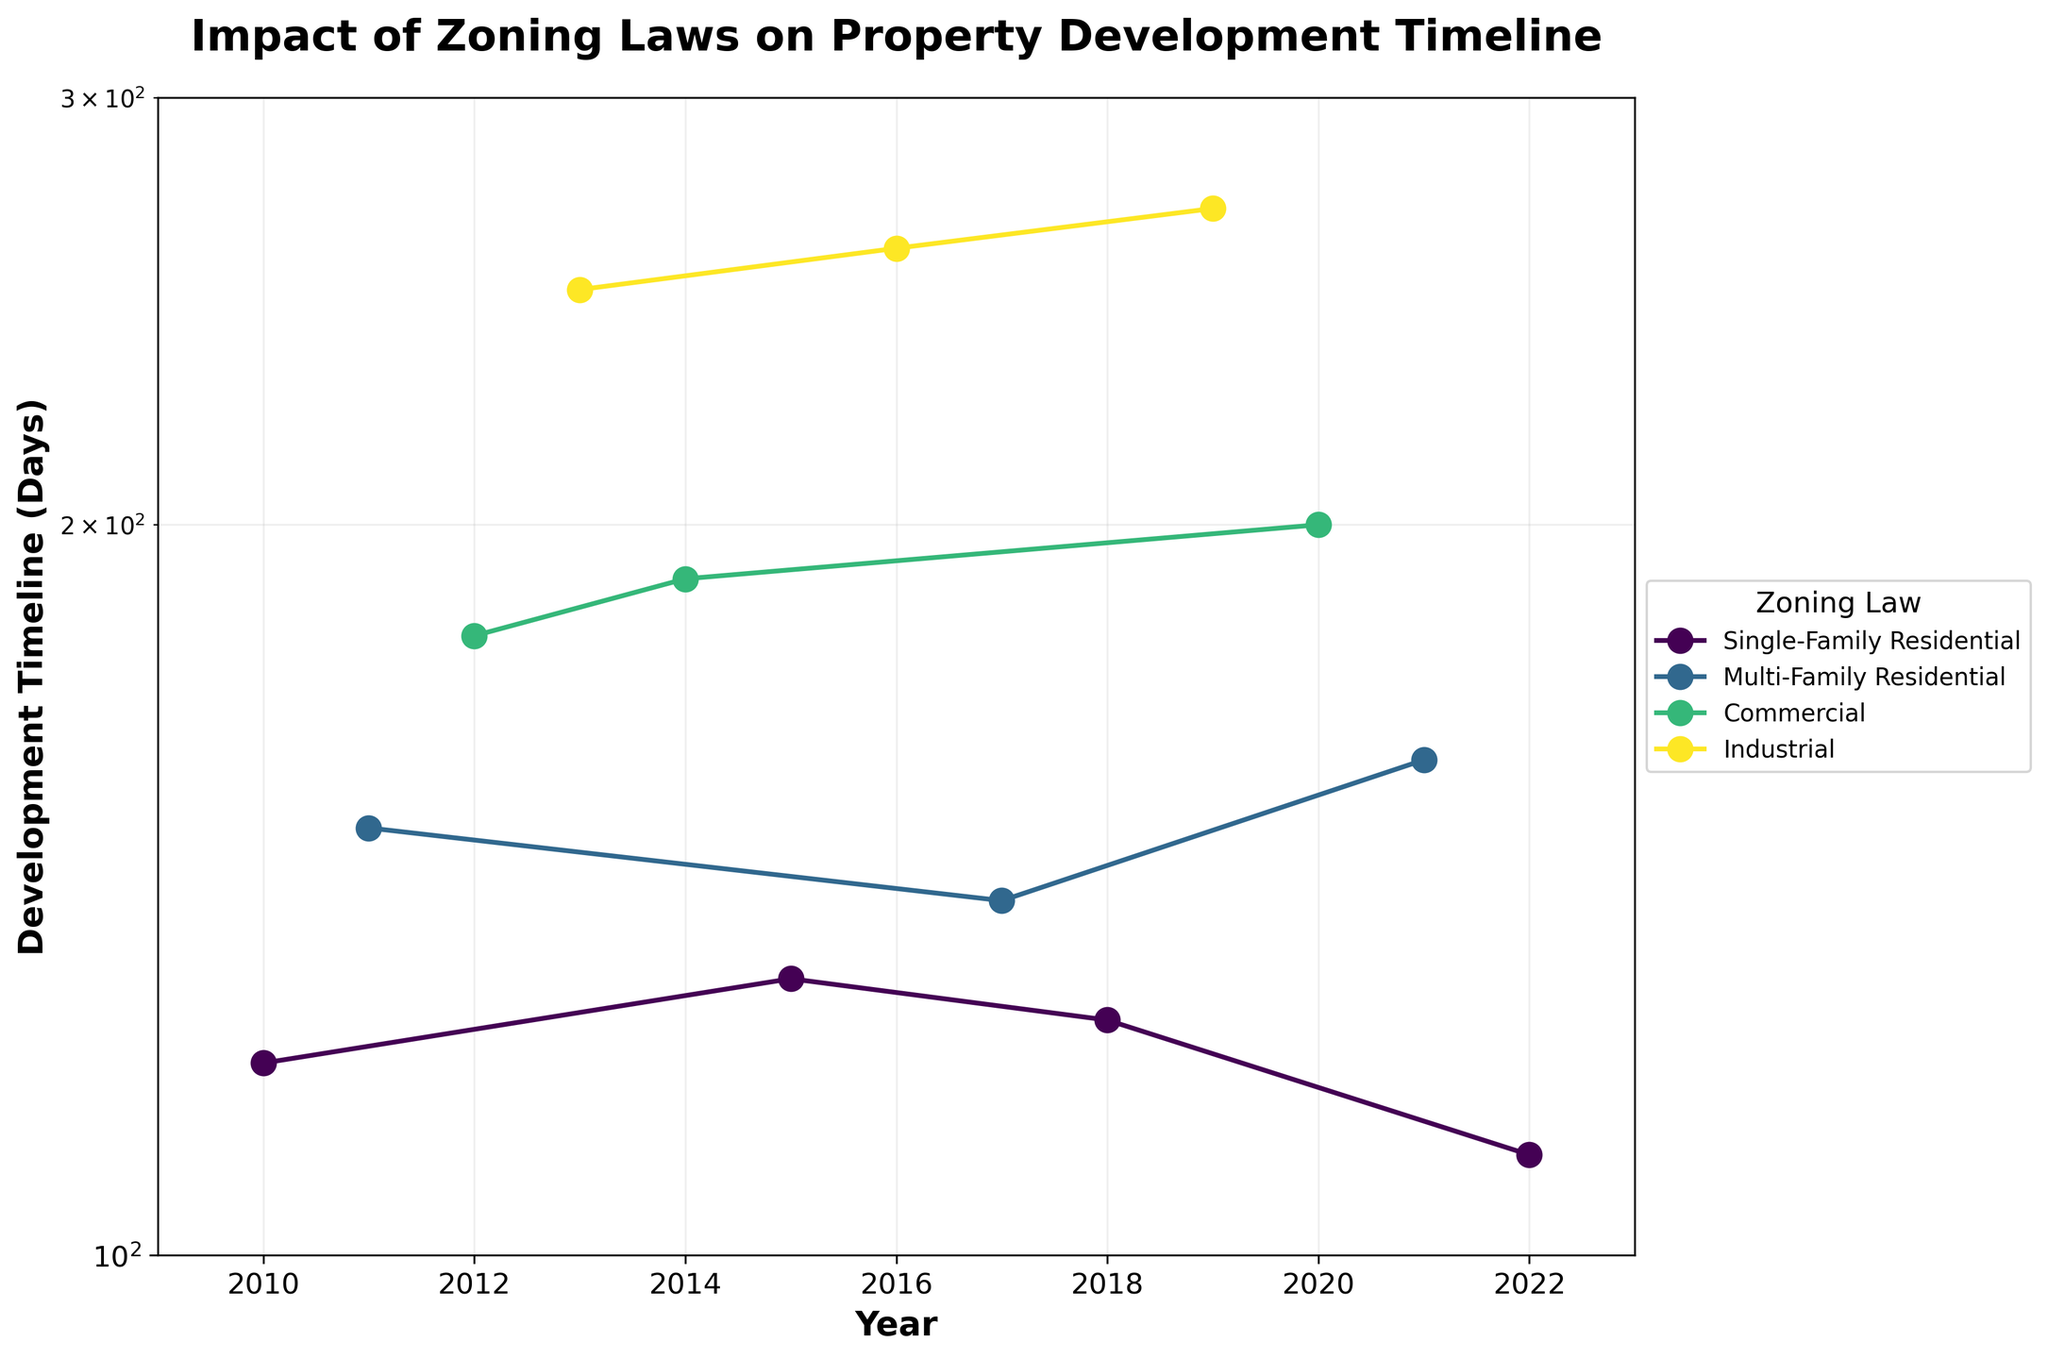What is the title of the figure? The title is located at the top of the figure and is usually a brief description of the content or purpose of the plot. From the data and the code provided, we know the title is: "Impact of Zoning Laws on Property Development Timeline".
Answer: Impact of Zoning Laws on Property Development Timeline What are the axis labels? The axis labels identify the variables plotted on each axis. According to the code, the x-axis is labeled 'Year' and the y-axis is labeled 'Development Timeline (Days)'.
Answer: Year, Development Timeline (Days) Which year has the lowest development timeline for Single-Family Residential zoning? By examining the line and markers for 'Single-Family Residential' zoning, the year with the lowest point on the y-axis is 2022.
Answer: 2022 How many years of data are presented in the figure? By looking at the x-axis, the plot appears to show data from 2010 to 2022, inclusive. Counting these years will give us 13 years of data.
Answer: 13 Which zoning law had the greatest increase in development timeline between two consecutive years? To determine this, check each zoning law individually and calculate the differences in development timelines for consecutive years. The largest difference appears between Industrial zoning in 2012 (180 days) and 2013 (250 days), an increase of 70 days.
Answer: Industrial What is the average development timeline for Commercial zoning across all years? To find the average, sum the development timelines for Commercial zoning in the years 2012, 2014, and 2020 and then divide by the number of points. (180 + 190 + 200) / 3 = 570 / 3 = 190.
Answer: 190 days In which year was the development timeline for Multi-Family Residential zoning the highest? Look at the line for Multi-Family Residential zoning and find the highest point on the y-axis, which occurs in 2011.
Answer: 2011 How does the variance in development timelines compare between Single-Family Residential and Industrial zoning? Calculate the variance for each category using the development timeline data. For Single-Family Residential: the data points are {120, 130, 125, 110} with a variance roughly around 66.67 days^2. For Industrial: the data points are {250, 260, 270} with a variance roughly around 55.56 days^2. Therefore, Single-Family Residential has a slightly higher variance.
Answer: Single-Family Residential has higher variance What kind of relationship (if any) is suggested between the type of zoning law and the development timeline? By looking at the overall trends in the plot, it's noted that some zoning laws (like Industrial) consistently have higher timelines compared to others (like Single-Family Residential). This suggests a potential correlation where certain zoning laws inherently require longer development times.
Answer: Certain zoning laws likely require longer timelines Which zoning law has the most consistent development timeline over the years? To determine consistency, look for the zoning law with the least fluctuation in development timelines each year. Single-Family Residential has relatively consistent values around 120-130 days, indicating it is the most stable.
Answer: Single-Family Residential 